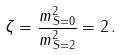Convert formula to latex. <formula><loc_0><loc_0><loc_500><loc_500>\zeta = \frac { m ^ { 2 } _ { S = 0 } } { m ^ { 2 } _ { S = 2 } } = 2 \, .</formula> 